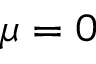Convert formula to latex. <formula><loc_0><loc_0><loc_500><loc_500>\mu = 0</formula> 